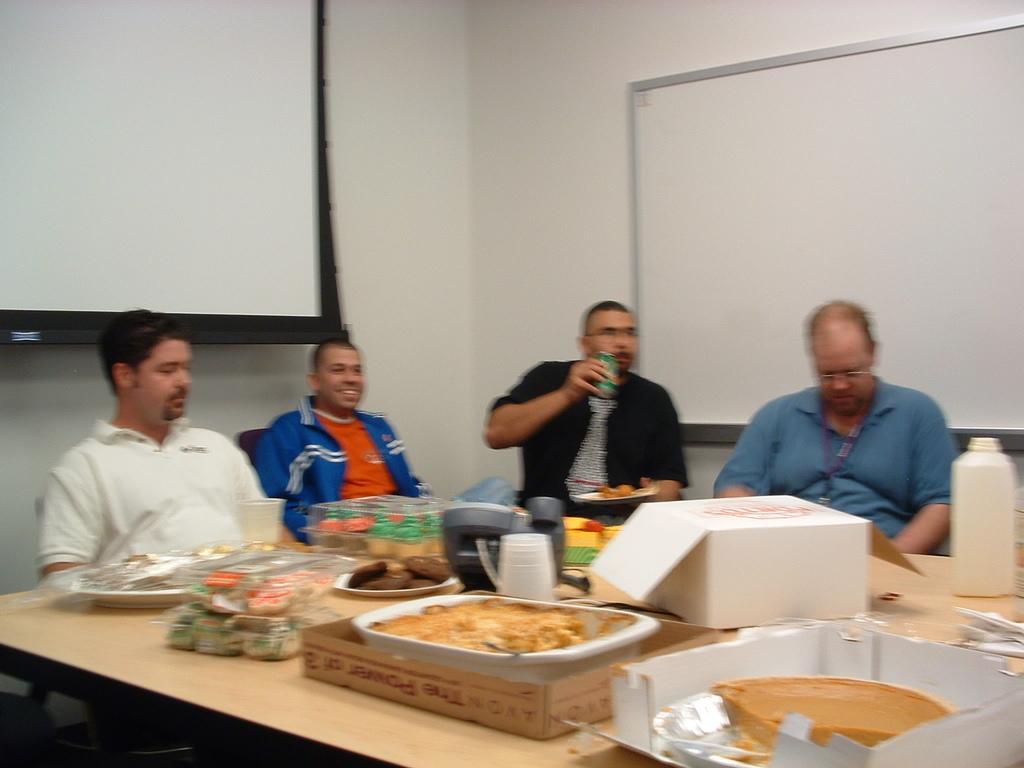Can you describe this image briefly? In this image few persons are sitting on the chair before a table having few boxes, plates and bottle on it. In box there is a tray having food. On plate there is some food in it. A person wearing a black shirt and tie is holding a coke can with one hand and plate with other hand. A person wearing a blue jacket is sitting. Behind him there is a display screen. Right side there is a white board attached to the wall. 